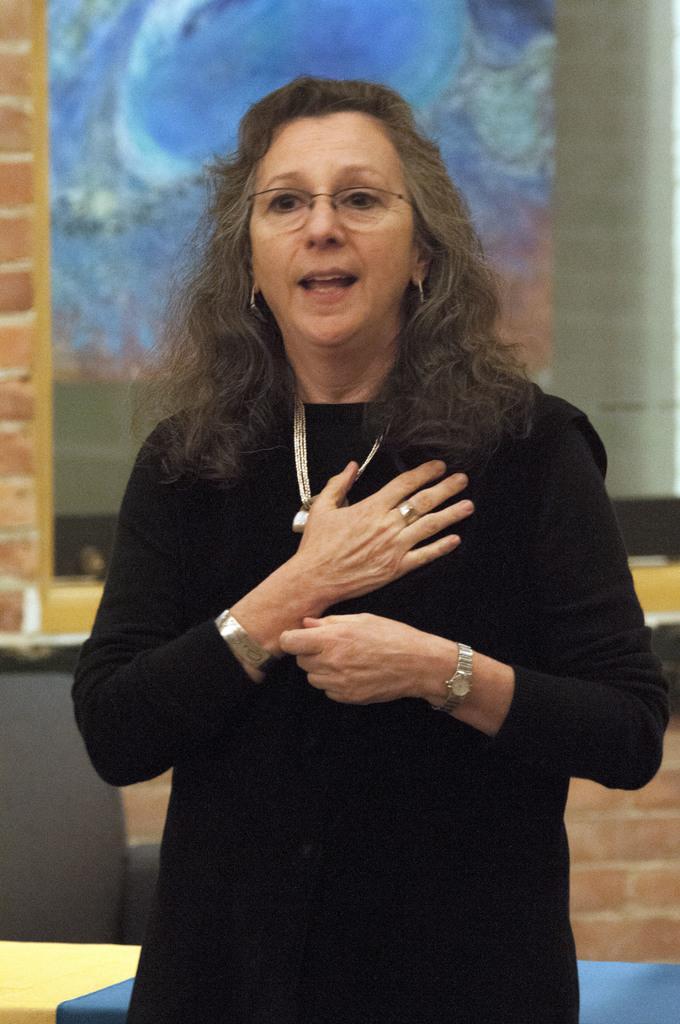Could you give a brief overview of what you see in this image? In this image I can see the person standing and the person is wearing black color dress and I can see the blue and brown color background. 